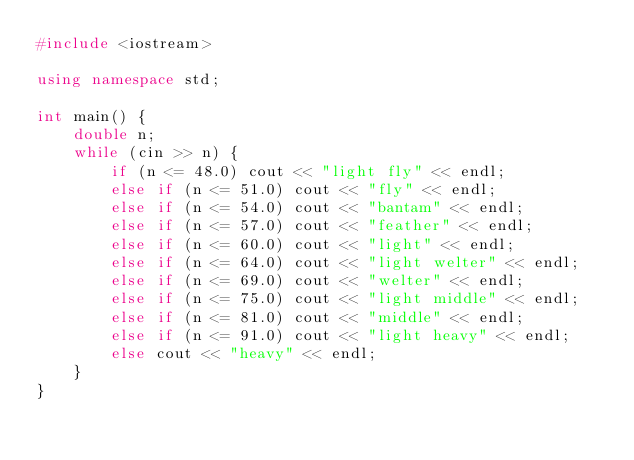<code> <loc_0><loc_0><loc_500><loc_500><_C++_>#include <iostream>

using namespace std;

int main() {
	double n;
	while (cin >> n) {
		if (n <= 48.0) cout << "light fly" << endl;
		else if (n <= 51.0) cout << "fly" << endl;
		else if (n <= 54.0) cout << "bantam" << endl;
		else if (n <= 57.0) cout << "feather" << endl;
		else if (n <= 60.0) cout << "light" << endl;
		else if (n <= 64.0) cout << "light welter" << endl;
		else if (n <= 69.0) cout << "welter" << endl;
		else if (n <= 75.0) cout << "light middle" << endl;
		else if (n <= 81.0) cout << "middle" << endl;
		else if (n <= 91.0) cout << "light heavy" << endl;
		else cout << "heavy" << endl;
	}
}</code> 